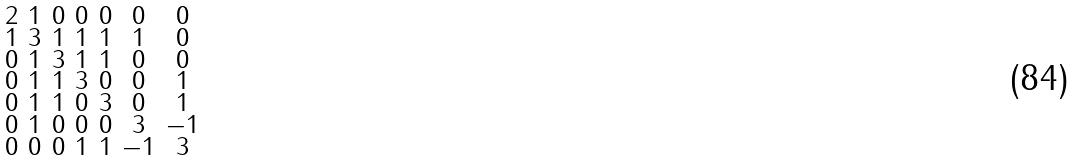<formula> <loc_0><loc_0><loc_500><loc_500>\begin{smallmatrix} 2 & 1 & 0 & 0 & 0 & 0 & 0 \\ 1 & 3 & 1 & 1 & 1 & 1 & 0 \\ 0 & 1 & 3 & 1 & 1 & 0 & 0 \\ 0 & 1 & 1 & 3 & 0 & 0 & 1 \\ 0 & 1 & 1 & 0 & 3 & 0 & 1 \\ 0 & 1 & 0 & 0 & 0 & 3 & - 1 \\ 0 & 0 & 0 & 1 & 1 & - 1 & 3 \end{smallmatrix}</formula> 